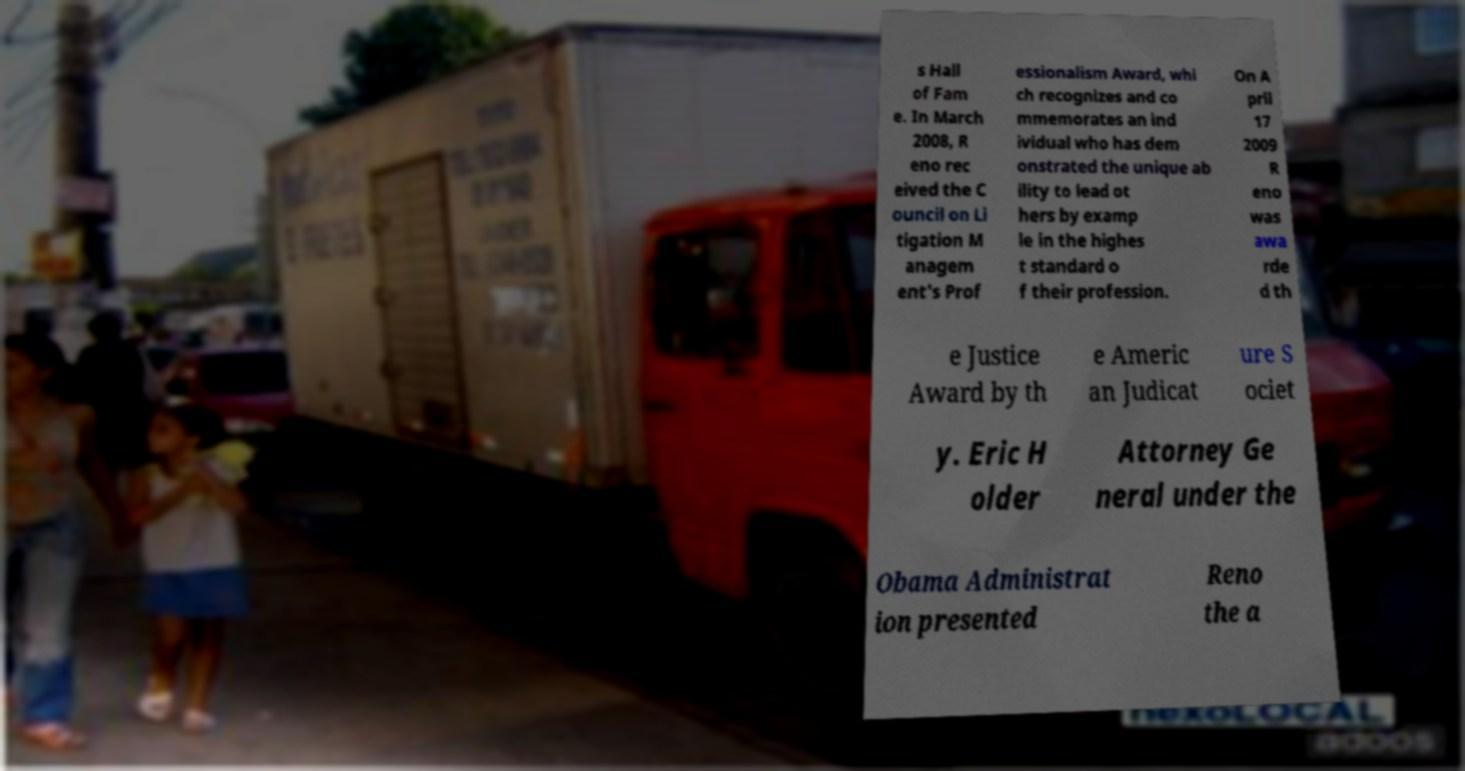Could you assist in decoding the text presented in this image and type it out clearly? Certainly, although the text in the image is partially obscured, here's a clearer transcription of the readable portions: '___ Hall of Fame. In March 2008, ___ received the Council on Litigation Management's Professionalism Award, which recognizes and commemorates an individual who has demonstrated the unique ability to lead others by example in the highest standard of their profession. On April 17, 2009, ___ was awarded the Justice Award by the ___ American Judicature Society. ___ Holder, Attorney General under the ___ Administration, presented ___ the award.' Unfortunately, the obscured words cannot be recovered from the image provided. 